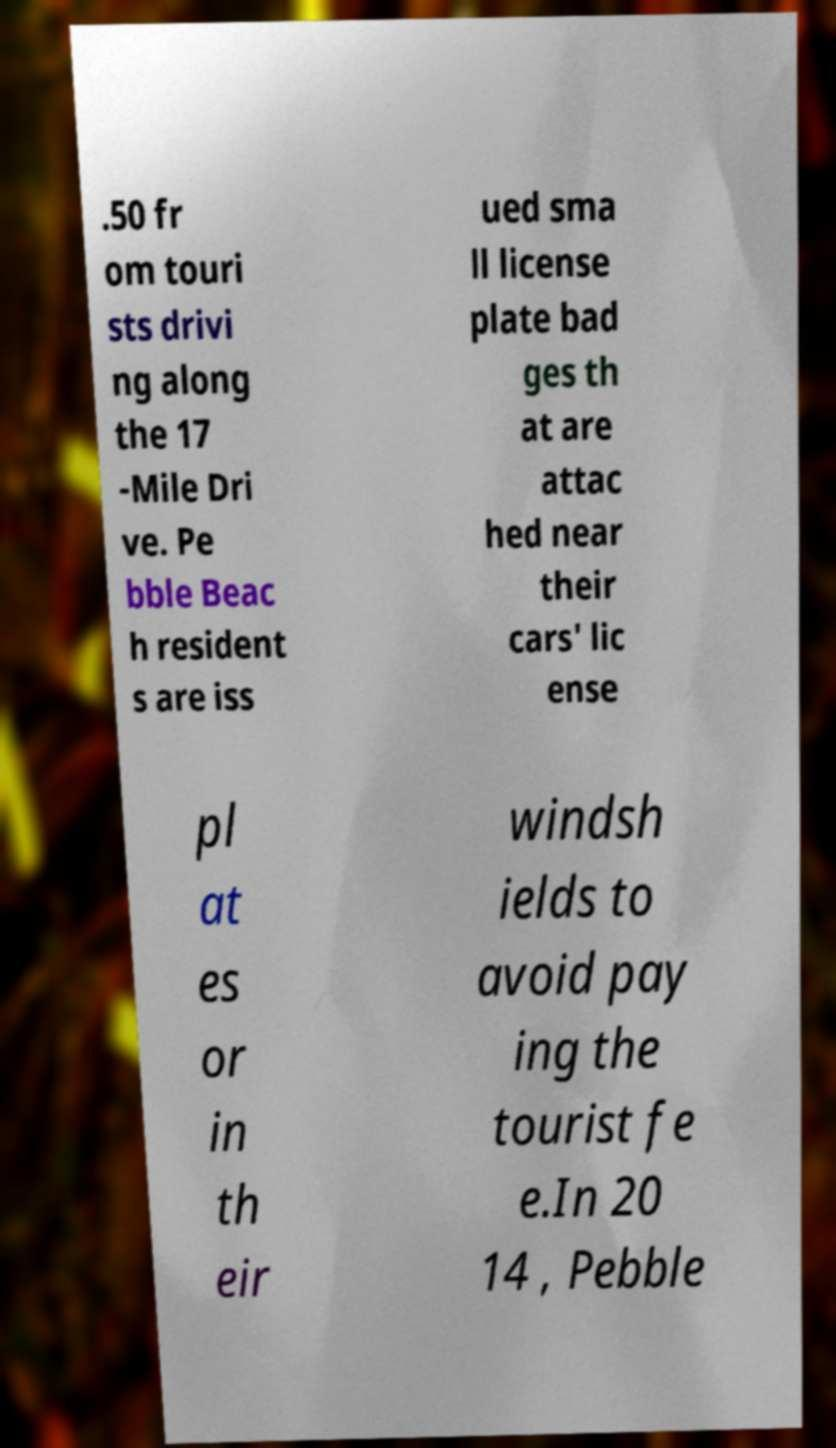Could you extract and type out the text from this image? .50 fr om touri sts drivi ng along the 17 -Mile Dri ve. Pe bble Beac h resident s are iss ued sma ll license plate bad ges th at are attac hed near their cars' lic ense pl at es or in th eir windsh ields to avoid pay ing the tourist fe e.In 20 14 , Pebble 